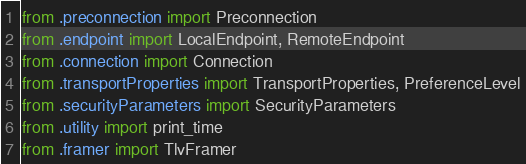Convert code to text. <code><loc_0><loc_0><loc_500><loc_500><_Python_>from .preconnection import Preconnection
from .endpoint import LocalEndpoint, RemoteEndpoint
from .connection import Connection
from .transportProperties import TransportProperties, PreferenceLevel
from .securityParameters import SecurityParameters
from .utility import print_time
from .framer import TlvFramer
</code> 